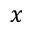<formula> <loc_0><loc_0><loc_500><loc_500>x</formula> 